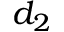Convert formula to latex. <formula><loc_0><loc_0><loc_500><loc_500>d _ { 2 }</formula> 